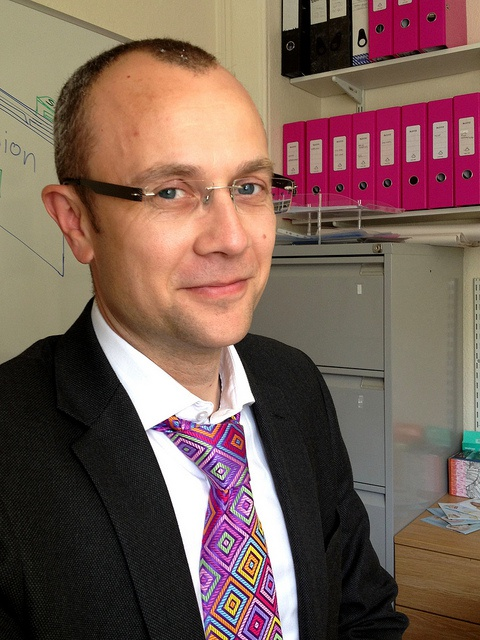Describe the objects in this image and their specific colors. I can see people in tan, black, salmon, and white tones, tie in tan and purple tones, book in tan, brown, and maroon tones, book in tan, brown, darkgray, and maroon tones, and book in tan and brown tones in this image. 